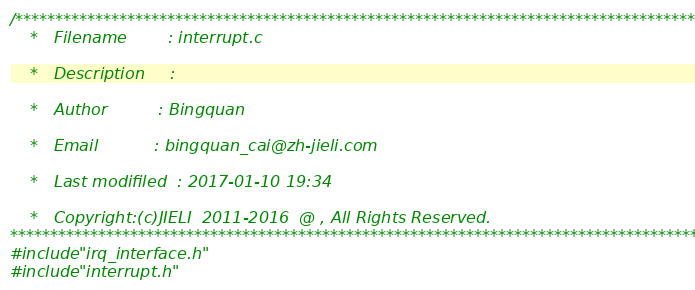<code> <loc_0><loc_0><loc_500><loc_500><_C_>/*********************************************************************************************
    *   Filename        : interrupt.c

    *   Description     :

    *   Author          : Bingquan

    *   Email           : bingquan_cai@zh-jieli.com

    *   Last modifiled  : 2017-01-10 19:34

    *   Copyright:(c)JIELI  2011-2016  @ , All Rights Reserved.
*********************************************************************************************/
#include "irq_interface.h"
#include "interrupt.h"</code> 